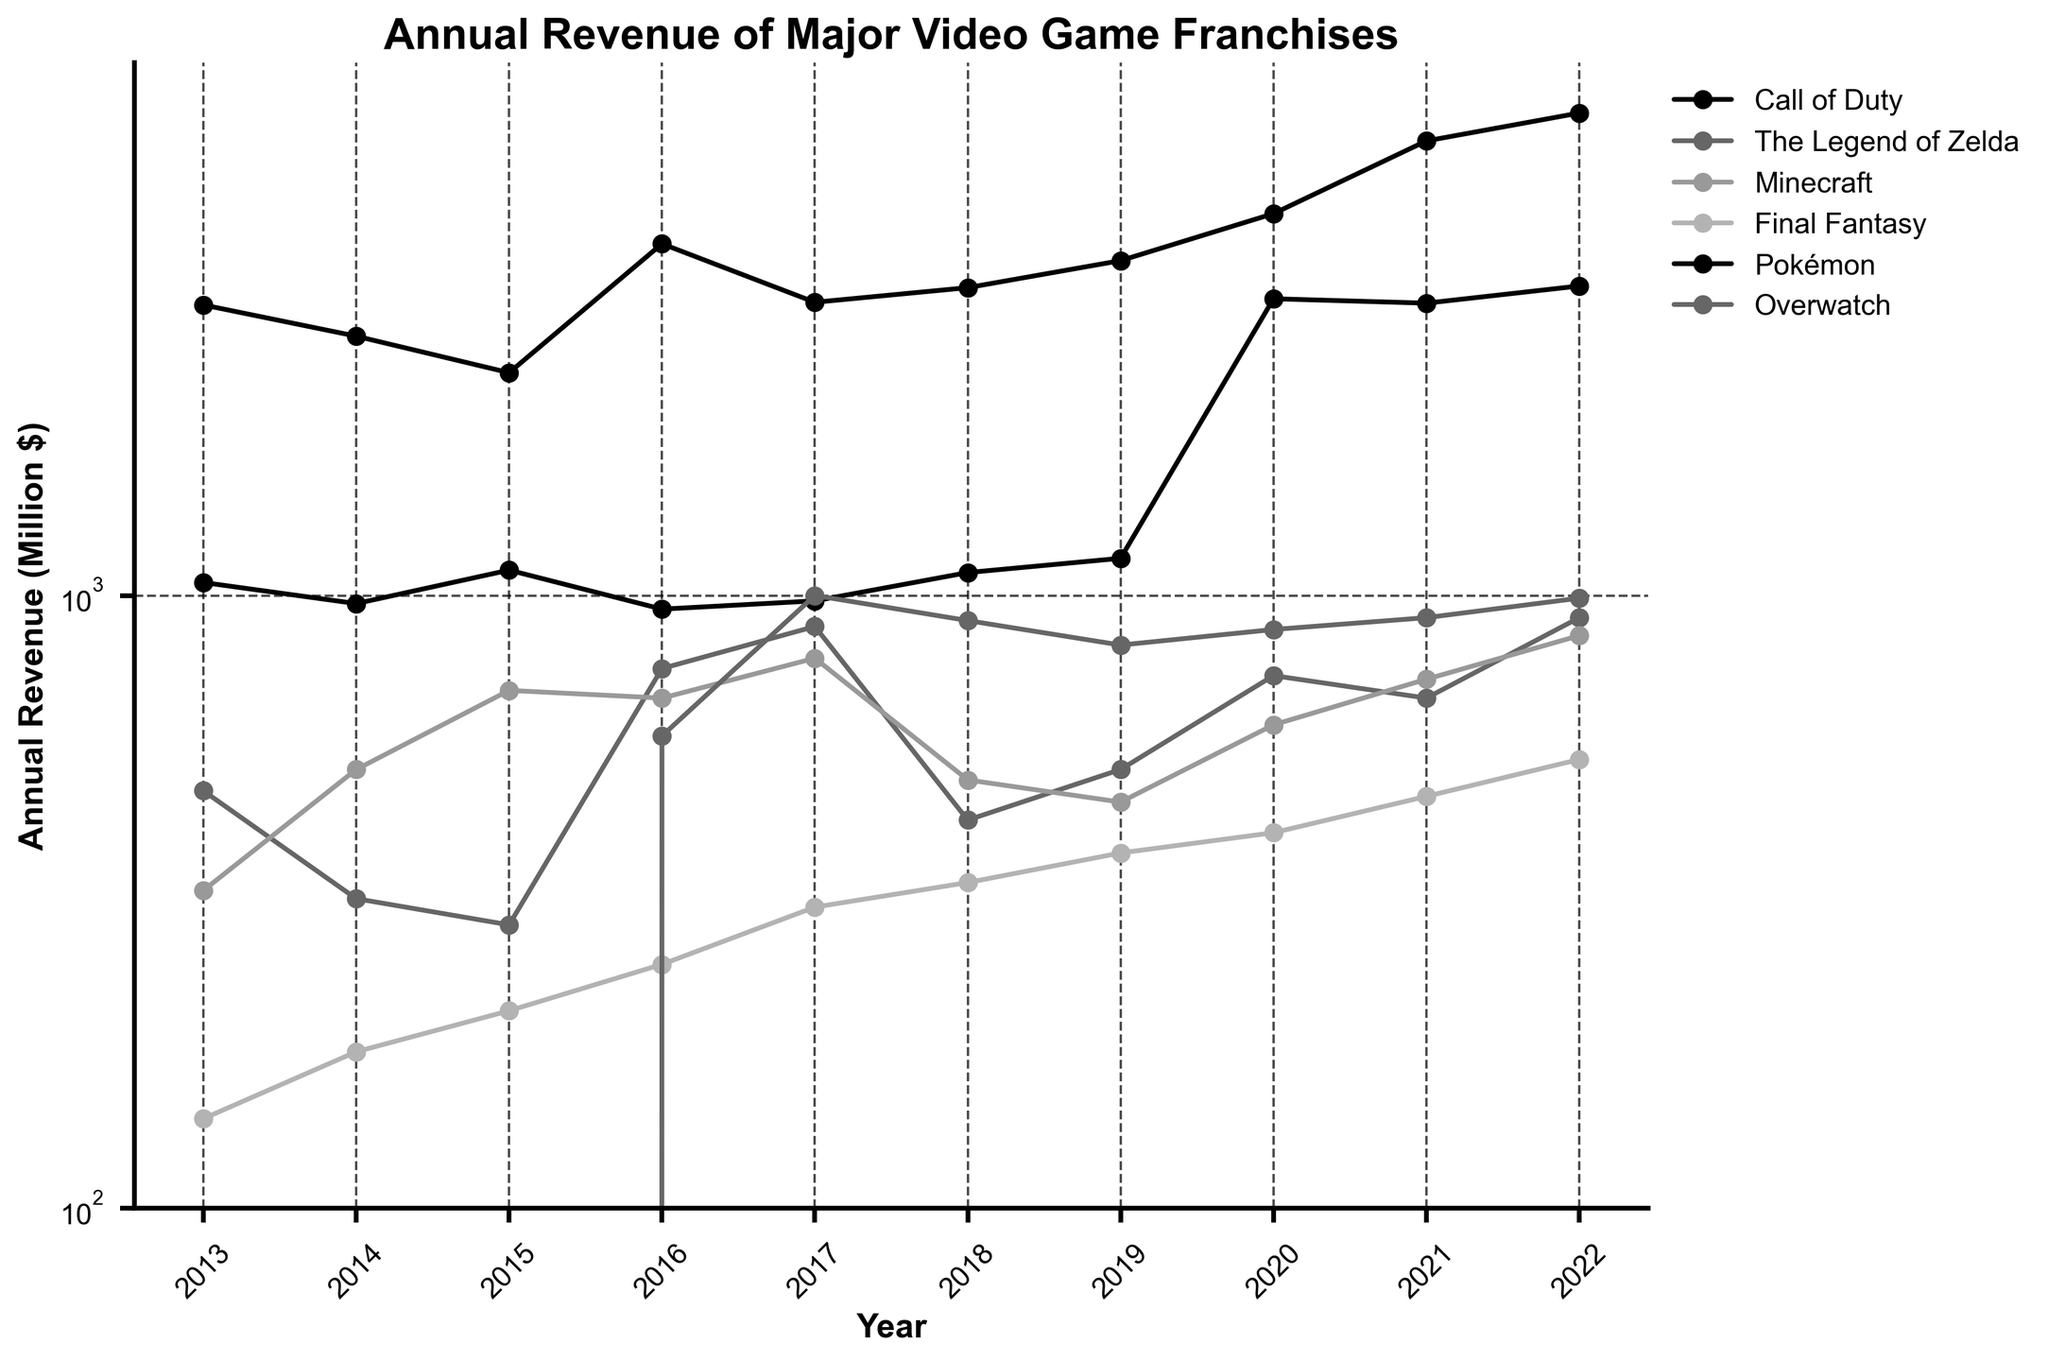What was the highest annual revenue for Call of Duty in the last decade? First, locate the 'Call of Duty' line on the plot. Then, identify the data point with the highest value along the y-axis. In this case, it appears in 2020 with a revenue of 3050 million dollars.
Answer: 3050 Compare the 2016 revenue of Overwatch with its 2017 revenue. Did it increase or decrease, and by how much? Locate the 'Overwatch' line on the plot and compare the 2016 and 2017 data points. For 2016, the revenue is 590 million dollars, and for 2017, it is 1000 million dollars. Calculate the difference: 1000 - 590 = 410. The revenue increased by 410 million dollars.
Answer: Increased by 410 Which franchise had the highest revenue in 2022? Look at the 2022 data points for all franchises and identify which data point is the highest. Pokémon has the highest revenue with 6130 million dollars.
Answer: Pokémon Calculate the average revenue of The Legend of Zelda from 2013 to 2022. Identify the data points for 'The Legend of Zelda' from 2013 to 2022. Sum these values: 480 + 320 + 290 + 760 + 890 + 430 + 520 + 740 + 680 + 920. The sum is 6030. There are 10 years, so the average is 6030 / 10 = 603.
Answer: 603 What trend can be observed about Minecraft's revenue between 2014 and 2016? Locate the 'Minecraft' line and observe the data points from 2014 to 2016. The values are 520 in 2014, 700 in 2015, and 680 in 2016. The revenue increased from 2014 to 2015 and then slightly decreased in 2016.
Answer: Increased then decreased Which franchise had the lowest revenue in 2013 and how much was it? Look at the 2013 data points and identify the lowest value. Final Fantasy had the lowest revenue with 140 million dollars.
Answer: Final Fantasy Between 2016 and 2017, which franchise had the largest percentage increase in revenue? Compare the percentage increases for all franchises between 2016 and 2017. Calculate the percentage increase using the formula: (New Value - Old Value) / Old Value * 100. Overwatch has the largest increase: (1000 - 590) / 590 * 100 ≈ 69.5%.
Answer: Overwatch Compare the revenues of Pokémon in 2020 and 2021. Did it increase or decrease, and by how much? Identify the 2020 and 2021 values for Pokémon. They are 4200 million dollars in 2020 and 5520 million dollars in 2021. Calculate the difference: 5520 - 4200 = 1320. The revenue increased by 1320 million dollars.
Answer: Increased by 1320 What was the difference in revenue between Minecraft and Final Fantasy in 2022? Locate the 2022 data points for both 'Minecraft' and 'Final Fantasy'. Minecraft's revenue is 860 million dollars, and Final Fantasy's revenue is 540 million dollars. Calculate the difference: 860 - 540 = 320.
Answer: 320 By how much did the revenue of The Legend of Zelda change from 2018 to 2019? Identify the 2018 and 2019 values for 'The Legend of Zelda'. They are 430 million dollars in 2018 and 520 million dollars in 2019. Calculate the difference: 520 - 430 = 90. The revenue increased by 90 million dollars.
Answer: Increased by 90 